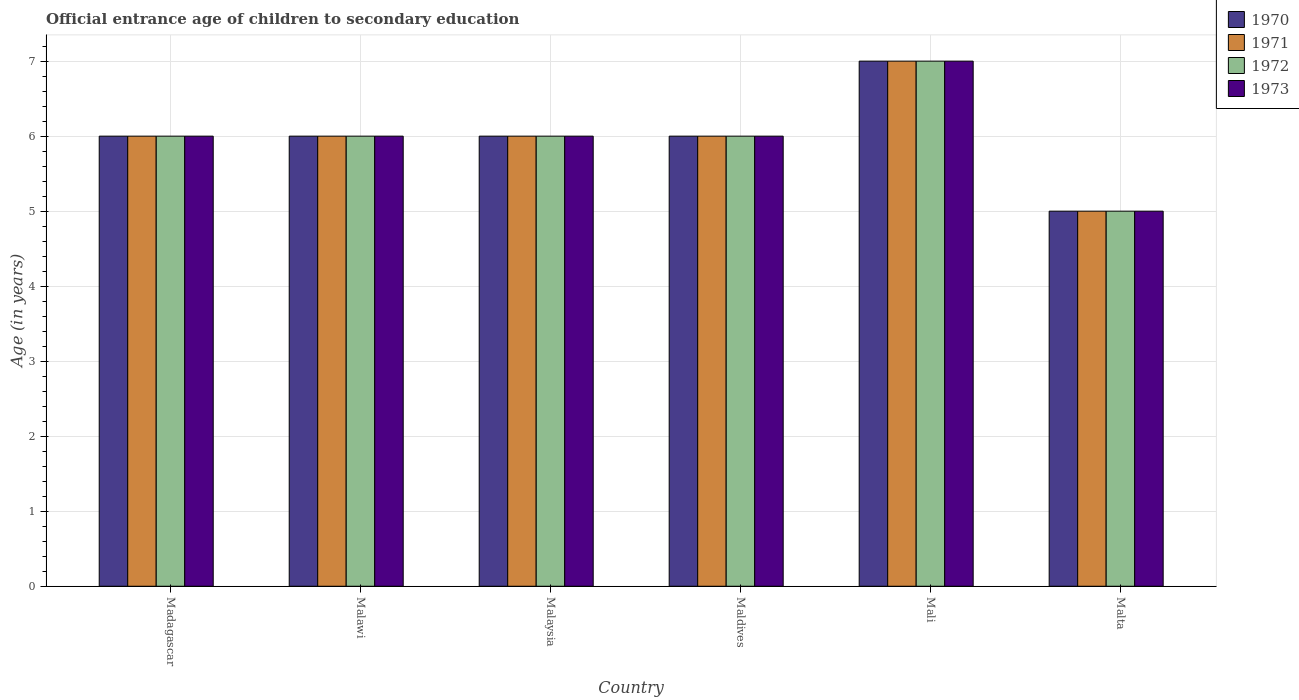How many different coloured bars are there?
Ensure brevity in your answer.  4. How many groups of bars are there?
Your response must be concise. 6. Are the number of bars per tick equal to the number of legend labels?
Give a very brief answer. Yes. How many bars are there on the 2nd tick from the left?
Make the answer very short. 4. How many bars are there on the 5th tick from the right?
Your answer should be compact. 4. What is the label of the 4th group of bars from the left?
Make the answer very short. Maldives. What is the secondary school starting age of children in 1973 in Malaysia?
Make the answer very short. 6. Across all countries, what is the maximum secondary school starting age of children in 1971?
Ensure brevity in your answer.  7. In which country was the secondary school starting age of children in 1973 maximum?
Your answer should be very brief. Mali. In which country was the secondary school starting age of children in 1972 minimum?
Ensure brevity in your answer.  Malta. What is the difference between the secondary school starting age of children in 1973 in Madagascar and that in Mali?
Provide a short and direct response. -1. What is the difference between the secondary school starting age of children of/in 1972 and secondary school starting age of children of/in 1973 in Malaysia?
Offer a very short reply. 0. Is the secondary school starting age of children in 1971 in Malaysia less than that in Malta?
Offer a very short reply. No. What is the difference between the highest and the second highest secondary school starting age of children in 1972?
Give a very brief answer. -1. What is the difference between the highest and the lowest secondary school starting age of children in 1973?
Offer a very short reply. 2. In how many countries, is the secondary school starting age of children in 1972 greater than the average secondary school starting age of children in 1972 taken over all countries?
Provide a succinct answer. 1. Is it the case that in every country, the sum of the secondary school starting age of children in 1971 and secondary school starting age of children in 1972 is greater than the sum of secondary school starting age of children in 1973 and secondary school starting age of children in 1970?
Your answer should be very brief. No. What does the 2nd bar from the right in Mali represents?
Offer a very short reply. 1972. How many bars are there?
Your answer should be compact. 24. Are all the bars in the graph horizontal?
Keep it short and to the point. No. What is the difference between two consecutive major ticks on the Y-axis?
Offer a very short reply. 1. Does the graph contain any zero values?
Provide a short and direct response. No. Where does the legend appear in the graph?
Give a very brief answer. Top right. What is the title of the graph?
Provide a short and direct response. Official entrance age of children to secondary education. Does "1997" appear as one of the legend labels in the graph?
Make the answer very short. No. What is the label or title of the X-axis?
Provide a succinct answer. Country. What is the label or title of the Y-axis?
Provide a short and direct response. Age (in years). What is the Age (in years) in 1972 in Madagascar?
Ensure brevity in your answer.  6. What is the Age (in years) in 1970 in Malawi?
Provide a succinct answer. 6. What is the Age (in years) in 1972 in Malawi?
Your response must be concise. 6. What is the Age (in years) of 1973 in Malawi?
Offer a very short reply. 6. What is the Age (in years) in 1972 in Malaysia?
Offer a very short reply. 6. What is the Age (in years) in 1973 in Malaysia?
Your response must be concise. 6. What is the Age (in years) of 1971 in Maldives?
Your answer should be compact. 6. What is the Age (in years) in 1973 in Mali?
Make the answer very short. 7. What is the Age (in years) in 1970 in Malta?
Your response must be concise. 5. Across all countries, what is the maximum Age (in years) in 1970?
Keep it short and to the point. 7. Across all countries, what is the maximum Age (in years) in 1972?
Make the answer very short. 7. Across all countries, what is the maximum Age (in years) in 1973?
Offer a terse response. 7. Across all countries, what is the minimum Age (in years) in 1970?
Ensure brevity in your answer.  5. Across all countries, what is the minimum Age (in years) in 1971?
Your response must be concise. 5. Across all countries, what is the minimum Age (in years) of 1972?
Ensure brevity in your answer.  5. What is the total Age (in years) in 1971 in the graph?
Provide a short and direct response. 36. What is the total Age (in years) of 1972 in the graph?
Your response must be concise. 36. What is the difference between the Age (in years) of 1970 in Madagascar and that in Malawi?
Offer a terse response. 0. What is the difference between the Age (in years) of 1973 in Madagascar and that in Malawi?
Provide a succinct answer. 0. What is the difference between the Age (in years) in 1972 in Madagascar and that in Malaysia?
Your answer should be compact. 0. What is the difference between the Age (in years) of 1970 in Madagascar and that in Maldives?
Keep it short and to the point. 0. What is the difference between the Age (in years) in 1971 in Madagascar and that in Mali?
Ensure brevity in your answer.  -1. What is the difference between the Age (in years) of 1972 in Madagascar and that in Mali?
Ensure brevity in your answer.  -1. What is the difference between the Age (in years) of 1972 in Malawi and that in Malaysia?
Offer a terse response. 0. What is the difference between the Age (in years) of 1971 in Malawi and that in Maldives?
Your answer should be very brief. 0. What is the difference between the Age (in years) in 1972 in Malawi and that in Maldives?
Offer a very short reply. 0. What is the difference between the Age (in years) of 1973 in Malawi and that in Maldives?
Keep it short and to the point. 0. What is the difference between the Age (in years) in 1970 in Malawi and that in Malta?
Offer a terse response. 1. What is the difference between the Age (in years) in 1971 in Malaysia and that in Mali?
Offer a very short reply. -1. What is the difference between the Age (in years) of 1970 in Malaysia and that in Malta?
Offer a terse response. 1. What is the difference between the Age (in years) in 1971 in Malaysia and that in Malta?
Your answer should be compact. 1. What is the difference between the Age (in years) in 1972 in Malaysia and that in Malta?
Your answer should be compact. 1. What is the difference between the Age (in years) of 1973 in Malaysia and that in Malta?
Your answer should be compact. 1. What is the difference between the Age (in years) of 1971 in Maldives and that in Mali?
Your answer should be very brief. -1. What is the difference between the Age (in years) in 1970 in Maldives and that in Malta?
Ensure brevity in your answer.  1. What is the difference between the Age (in years) of 1973 in Maldives and that in Malta?
Make the answer very short. 1. What is the difference between the Age (in years) in 1970 in Madagascar and the Age (in years) in 1973 in Malawi?
Your response must be concise. 0. What is the difference between the Age (in years) of 1971 in Madagascar and the Age (in years) of 1972 in Malawi?
Offer a very short reply. 0. What is the difference between the Age (in years) of 1971 in Madagascar and the Age (in years) of 1973 in Malawi?
Ensure brevity in your answer.  0. What is the difference between the Age (in years) of 1972 in Madagascar and the Age (in years) of 1973 in Malawi?
Offer a very short reply. 0. What is the difference between the Age (in years) in 1970 in Madagascar and the Age (in years) in 1972 in Malaysia?
Provide a succinct answer. 0. What is the difference between the Age (in years) of 1970 in Madagascar and the Age (in years) of 1973 in Malaysia?
Provide a short and direct response. 0. What is the difference between the Age (in years) of 1971 in Madagascar and the Age (in years) of 1973 in Malaysia?
Provide a succinct answer. 0. What is the difference between the Age (in years) in 1972 in Madagascar and the Age (in years) in 1973 in Malaysia?
Ensure brevity in your answer.  0. What is the difference between the Age (in years) of 1970 in Madagascar and the Age (in years) of 1971 in Maldives?
Give a very brief answer. 0. What is the difference between the Age (in years) of 1970 in Madagascar and the Age (in years) of 1971 in Mali?
Provide a short and direct response. -1. What is the difference between the Age (in years) in 1970 in Madagascar and the Age (in years) in 1972 in Mali?
Your answer should be compact. -1. What is the difference between the Age (in years) in 1970 in Madagascar and the Age (in years) in 1973 in Mali?
Your answer should be very brief. -1. What is the difference between the Age (in years) of 1971 in Madagascar and the Age (in years) of 1972 in Mali?
Ensure brevity in your answer.  -1. What is the difference between the Age (in years) in 1971 in Madagascar and the Age (in years) in 1973 in Mali?
Offer a terse response. -1. What is the difference between the Age (in years) of 1972 in Madagascar and the Age (in years) of 1973 in Mali?
Provide a short and direct response. -1. What is the difference between the Age (in years) in 1970 in Madagascar and the Age (in years) in 1971 in Malta?
Keep it short and to the point. 1. What is the difference between the Age (in years) of 1971 in Madagascar and the Age (in years) of 1972 in Malta?
Make the answer very short. 1. What is the difference between the Age (in years) in 1972 in Madagascar and the Age (in years) in 1973 in Malta?
Ensure brevity in your answer.  1. What is the difference between the Age (in years) in 1970 in Malawi and the Age (in years) in 1971 in Malaysia?
Provide a short and direct response. 0. What is the difference between the Age (in years) in 1970 in Malawi and the Age (in years) in 1972 in Malaysia?
Ensure brevity in your answer.  0. What is the difference between the Age (in years) in 1971 in Malawi and the Age (in years) in 1973 in Malaysia?
Your answer should be compact. 0. What is the difference between the Age (in years) of 1972 in Malawi and the Age (in years) of 1973 in Malaysia?
Offer a terse response. 0. What is the difference between the Age (in years) of 1971 in Malawi and the Age (in years) of 1973 in Maldives?
Your answer should be compact. 0. What is the difference between the Age (in years) of 1972 in Malawi and the Age (in years) of 1973 in Maldives?
Your answer should be compact. 0. What is the difference between the Age (in years) in 1970 in Malawi and the Age (in years) in 1971 in Mali?
Your response must be concise. -1. What is the difference between the Age (in years) in 1970 in Malawi and the Age (in years) in 1973 in Mali?
Provide a short and direct response. -1. What is the difference between the Age (in years) of 1971 in Malawi and the Age (in years) of 1972 in Mali?
Offer a terse response. -1. What is the difference between the Age (in years) of 1970 in Malawi and the Age (in years) of 1972 in Malta?
Your answer should be very brief. 1. What is the difference between the Age (in years) in 1970 in Malawi and the Age (in years) in 1973 in Malta?
Ensure brevity in your answer.  1. What is the difference between the Age (in years) in 1971 in Malawi and the Age (in years) in 1973 in Malta?
Offer a very short reply. 1. What is the difference between the Age (in years) in 1972 in Malawi and the Age (in years) in 1973 in Malta?
Offer a terse response. 1. What is the difference between the Age (in years) in 1970 in Malaysia and the Age (in years) in 1972 in Maldives?
Your answer should be very brief. 0. What is the difference between the Age (in years) of 1970 in Malaysia and the Age (in years) of 1973 in Maldives?
Provide a succinct answer. 0. What is the difference between the Age (in years) in 1971 in Malaysia and the Age (in years) in 1972 in Maldives?
Your response must be concise. 0. What is the difference between the Age (in years) of 1972 in Malaysia and the Age (in years) of 1973 in Maldives?
Provide a succinct answer. 0. What is the difference between the Age (in years) of 1970 in Malaysia and the Age (in years) of 1973 in Mali?
Your response must be concise. -1. What is the difference between the Age (in years) of 1972 in Malaysia and the Age (in years) of 1973 in Mali?
Give a very brief answer. -1. What is the difference between the Age (in years) of 1970 in Malaysia and the Age (in years) of 1972 in Malta?
Keep it short and to the point. 1. What is the difference between the Age (in years) in 1970 in Malaysia and the Age (in years) in 1973 in Malta?
Your response must be concise. 1. What is the difference between the Age (in years) of 1970 in Maldives and the Age (in years) of 1971 in Mali?
Make the answer very short. -1. What is the difference between the Age (in years) in 1970 in Maldives and the Age (in years) in 1973 in Mali?
Provide a short and direct response. -1. What is the difference between the Age (in years) in 1971 in Maldives and the Age (in years) in 1972 in Mali?
Offer a very short reply. -1. What is the difference between the Age (in years) in 1970 in Maldives and the Age (in years) in 1972 in Malta?
Provide a succinct answer. 1. What is the difference between the Age (in years) in 1970 in Maldives and the Age (in years) in 1973 in Malta?
Your answer should be very brief. 1. What is the difference between the Age (in years) of 1972 in Maldives and the Age (in years) of 1973 in Malta?
Your response must be concise. 1. What is the difference between the Age (in years) of 1970 in Mali and the Age (in years) of 1971 in Malta?
Ensure brevity in your answer.  2. What is the difference between the Age (in years) in 1971 in Mali and the Age (in years) in 1973 in Malta?
Offer a very short reply. 2. What is the average Age (in years) in 1970 per country?
Provide a short and direct response. 6. What is the average Age (in years) in 1971 per country?
Keep it short and to the point. 6. What is the average Age (in years) of 1972 per country?
Your response must be concise. 6. What is the average Age (in years) in 1973 per country?
Provide a short and direct response. 6. What is the difference between the Age (in years) of 1971 and Age (in years) of 1972 in Madagascar?
Keep it short and to the point. 0. What is the difference between the Age (in years) in 1971 and Age (in years) in 1973 in Madagascar?
Offer a very short reply. 0. What is the difference between the Age (in years) in 1970 and Age (in years) in 1971 in Malawi?
Provide a short and direct response. 0. What is the difference between the Age (in years) of 1970 and Age (in years) of 1972 in Malawi?
Provide a succinct answer. 0. What is the difference between the Age (in years) of 1971 and Age (in years) of 1972 in Malawi?
Offer a very short reply. 0. What is the difference between the Age (in years) of 1970 and Age (in years) of 1971 in Malaysia?
Keep it short and to the point. 0. What is the difference between the Age (in years) of 1970 and Age (in years) of 1972 in Malaysia?
Offer a very short reply. 0. What is the difference between the Age (in years) of 1971 and Age (in years) of 1973 in Malaysia?
Offer a very short reply. 0. What is the difference between the Age (in years) in 1972 and Age (in years) in 1973 in Malaysia?
Offer a terse response. 0. What is the difference between the Age (in years) of 1971 and Age (in years) of 1973 in Maldives?
Provide a short and direct response. 0. What is the difference between the Age (in years) in 1972 and Age (in years) in 1973 in Maldives?
Keep it short and to the point. 0. What is the difference between the Age (in years) of 1970 and Age (in years) of 1972 in Mali?
Make the answer very short. 0. What is the difference between the Age (in years) of 1971 and Age (in years) of 1972 in Mali?
Offer a terse response. 0. What is the difference between the Age (in years) in 1971 and Age (in years) in 1973 in Mali?
Provide a succinct answer. 0. What is the difference between the Age (in years) in 1970 and Age (in years) in 1972 in Malta?
Give a very brief answer. 0. What is the difference between the Age (in years) in 1970 and Age (in years) in 1973 in Malta?
Ensure brevity in your answer.  0. What is the difference between the Age (in years) in 1971 and Age (in years) in 1972 in Malta?
Your response must be concise. 0. What is the difference between the Age (in years) of 1971 and Age (in years) of 1973 in Malta?
Make the answer very short. 0. What is the ratio of the Age (in years) of 1970 in Madagascar to that in Malawi?
Give a very brief answer. 1. What is the ratio of the Age (in years) in 1972 in Madagascar to that in Malawi?
Offer a terse response. 1. What is the ratio of the Age (in years) of 1971 in Madagascar to that in Malaysia?
Provide a succinct answer. 1. What is the ratio of the Age (in years) of 1973 in Madagascar to that in Malaysia?
Your answer should be compact. 1. What is the ratio of the Age (in years) of 1970 in Madagascar to that in Maldives?
Your response must be concise. 1. What is the ratio of the Age (in years) of 1972 in Madagascar to that in Maldives?
Ensure brevity in your answer.  1. What is the ratio of the Age (in years) in 1970 in Madagascar to that in Mali?
Keep it short and to the point. 0.86. What is the ratio of the Age (in years) of 1971 in Madagascar to that in Mali?
Your answer should be very brief. 0.86. What is the ratio of the Age (in years) of 1972 in Madagascar to that in Mali?
Provide a short and direct response. 0.86. What is the ratio of the Age (in years) of 1973 in Madagascar to that in Mali?
Your answer should be very brief. 0.86. What is the ratio of the Age (in years) of 1970 in Madagascar to that in Malta?
Ensure brevity in your answer.  1.2. What is the ratio of the Age (in years) of 1971 in Madagascar to that in Malta?
Give a very brief answer. 1.2. What is the ratio of the Age (in years) in 1973 in Madagascar to that in Malta?
Provide a succinct answer. 1.2. What is the ratio of the Age (in years) of 1972 in Malawi to that in Malaysia?
Give a very brief answer. 1. What is the ratio of the Age (in years) in 1970 in Malawi to that in Maldives?
Offer a very short reply. 1. What is the ratio of the Age (in years) in 1971 in Malawi to that in Maldives?
Offer a very short reply. 1. What is the ratio of the Age (in years) in 1972 in Malawi to that in Maldives?
Your response must be concise. 1. What is the ratio of the Age (in years) in 1973 in Malawi to that in Mali?
Make the answer very short. 0.86. What is the ratio of the Age (in years) in 1971 in Malawi to that in Malta?
Provide a short and direct response. 1.2. What is the ratio of the Age (in years) of 1972 in Malawi to that in Malta?
Your response must be concise. 1.2. What is the ratio of the Age (in years) in 1973 in Malaysia to that in Maldives?
Your answer should be very brief. 1. What is the ratio of the Age (in years) of 1972 in Malaysia to that in Mali?
Make the answer very short. 0.86. What is the ratio of the Age (in years) in 1970 in Malaysia to that in Malta?
Offer a terse response. 1.2. What is the ratio of the Age (in years) of 1972 in Malaysia to that in Malta?
Make the answer very short. 1.2. What is the ratio of the Age (in years) in 1973 in Malaysia to that in Malta?
Ensure brevity in your answer.  1.2. What is the ratio of the Age (in years) in 1971 in Maldives to that in Malta?
Your response must be concise. 1.2. What is the ratio of the Age (in years) of 1972 in Maldives to that in Malta?
Offer a terse response. 1.2. What is the ratio of the Age (in years) in 1973 in Maldives to that in Malta?
Ensure brevity in your answer.  1.2. What is the ratio of the Age (in years) in 1971 in Mali to that in Malta?
Provide a succinct answer. 1.4. What is the ratio of the Age (in years) in 1972 in Mali to that in Malta?
Your answer should be compact. 1.4. What is the difference between the highest and the second highest Age (in years) of 1972?
Your answer should be compact. 1. What is the difference between the highest and the lowest Age (in years) of 1970?
Offer a terse response. 2. 